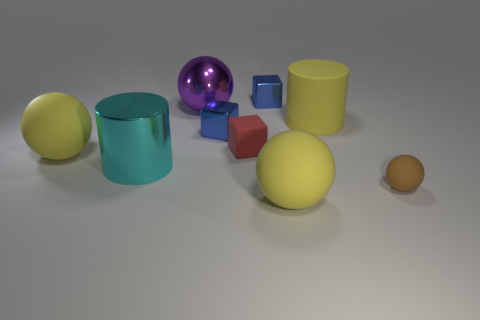What number of objects are rubber balls that are in front of the brown object or rubber balls that are to the left of the purple thing?
Keep it short and to the point. 2. There is a small matte object on the left side of the tiny brown matte sphere; is its color the same as the small cube that is on the right side of the red object?
Offer a terse response. No. What is the shape of the big thing that is both on the right side of the red object and in front of the small red block?
Your answer should be very brief. Sphere. There is another metal object that is the same size as the cyan thing; what is its color?
Offer a terse response. Purple. Is there a small matte sphere of the same color as the big shiny cylinder?
Offer a terse response. No. There is a sphere that is to the left of the big metallic cylinder; is its size the same as the yellow rubber sphere in front of the small brown rubber ball?
Give a very brief answer. Yes. There is a big yellow object that is on the left side of the big matte cylinder and behind the large cyan thing; what material is it made of?
Provide a short and direct response. Rubber. What number of other things are there of the same size as the purple sphere?
Your answer should be compact. 4. There is a big yellow ball that is in front of the tiny brown rubber object; what is its material?
Keep it short and to the point. Rubber. Do the red matte thing and the tiny brown matte thing have the same shape?
Ensure brevity in your answer.  No. 